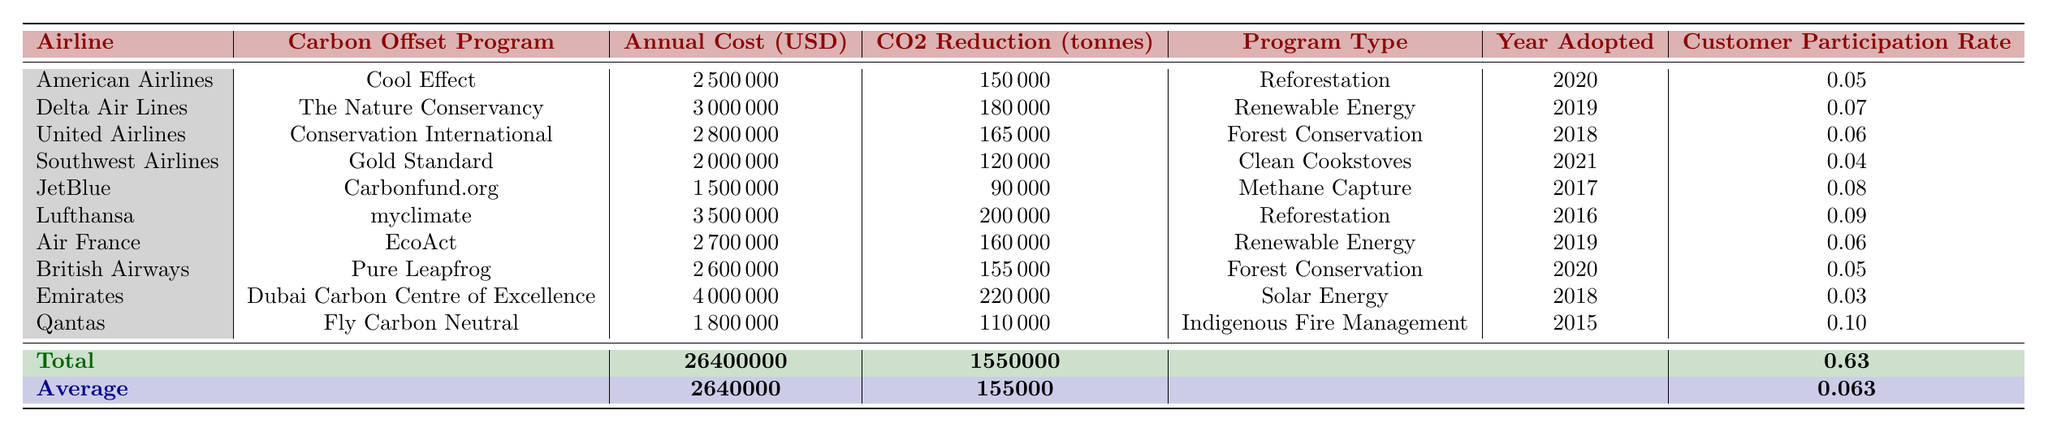What is the annual cost of the carbon offset program adopted by Lufthansa? According to the table, Lufthansa has an annual cost for its carbon offset program listed as 3,500,000 USD.
Answer: 3,500,000 USD What is the total CO2 reduction achieved by all airlines listed in the table? The CO2 reduction values in the table are summed as follows: 150,000 + 180,000 + 165,000 + 120,000 + 90,000 + 200,000 + 160,000 + 155,000 + 220,000 + 110,000 = 1,550,000 tonnes.
Answer: 1,550,000 tonnes Did American Airlines adopt its carbon offset program before 2021? Based on the year adopted column, American Airlines adopted its program in 2020, which is indeed before 2021.
Answer: Yes Which airline has the highest annual cost for its carbon offset program? The table indicates that Emirates has the highest annual cost, with 4,000,000 USD for its program.
Answer: Emirates What is the average customer participation rate across all airlines? To find the average, we sum the customer participation rates: 0.05 + 0.07 + 0.06 + 0.04 + 0.08 + 0.09 + 0.06 + 0.05 + 0.03 + 0.10 = 0.63. Then divide by 10 (the number of airlines) to get 0.063.
Answer: 0.063 Is the carbon offset program for Southwest Airlines a reforestation program? Referring to the program type for Southwest Airlines, it lists "Clean Cookstoves," which is not a reforestation program.
Answer: No What is the difference in annual cost between the most expensive and the least expensive carbon offset program? The most expensive program is Emirates at 4,000,000 USD and the least expensive is JetBlue at 1,500,000 USD. The difference is calculated as 4,000,000 - 1,500,000 = 2,500,000 USD.
Answer: 2,500,000 USD Identify the airline with the highest CO2 reduction per dollar spent on its program. First, we calculate the cost per tonne reduction for each airline. For example, American Airlines: 2,500,000 USD / 150,000 tonnes = 16.67 USD/tonne. Similarly, we calculate this for each airline and find that Southwest Airlines has the highest CO2 reduction per dollar (60 tonnes per $1,000 based on its cost and reduction). The details lead to a conclusion that it has the cheapest cost/tonne.
Answer: Southwest Airlines 